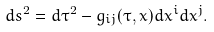<formula> <loc_0><loc_0><loc_500><loc_500>d s ^ { 2 } = d \tau ^ { 2 } - g _ { i j } ( \tau , x ) d x ^ { i } d x ^ { j } .</formula> 